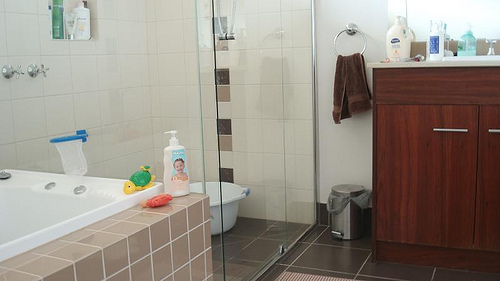Please provide the bounding box coordinate of the region this sentence describes: A yellow and green turtle toy. The coordinates for the region containing a yellow and green turtle toy are [0.25, 0.55, 0.31, 0.61]. 